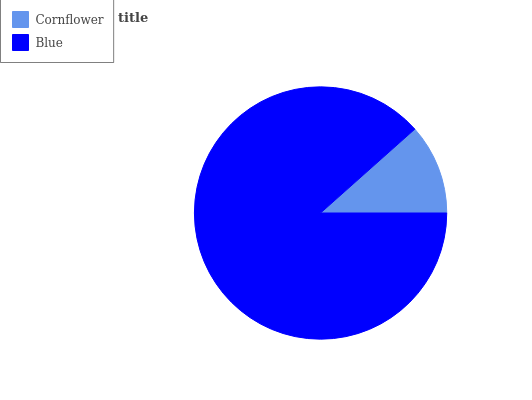Is Cornflower the minimum?
Answer yes or no. Yes. Is Blue the maximum?
Answer yes or no. Yes. Is Blue the minimum?
Answer yes or no. No. Is Blue greater than Cornflower?
Answer yes or no. Yes. Is Cornflower less than Blue?
Answer yes or no. Yes. Is Cornflower greater than Blue?
Answer yes or no. No. Is Blue less than Cornflower?
Answer yes or no. No. Is Blue the high median?
Answer yes or no. Yes. Is Cornflower the low median?
Answer yes or no. Yes. Is Cornflower the high median?
Answer yes or no. No. Is Blue the low median?
Answer yes or no. No. 